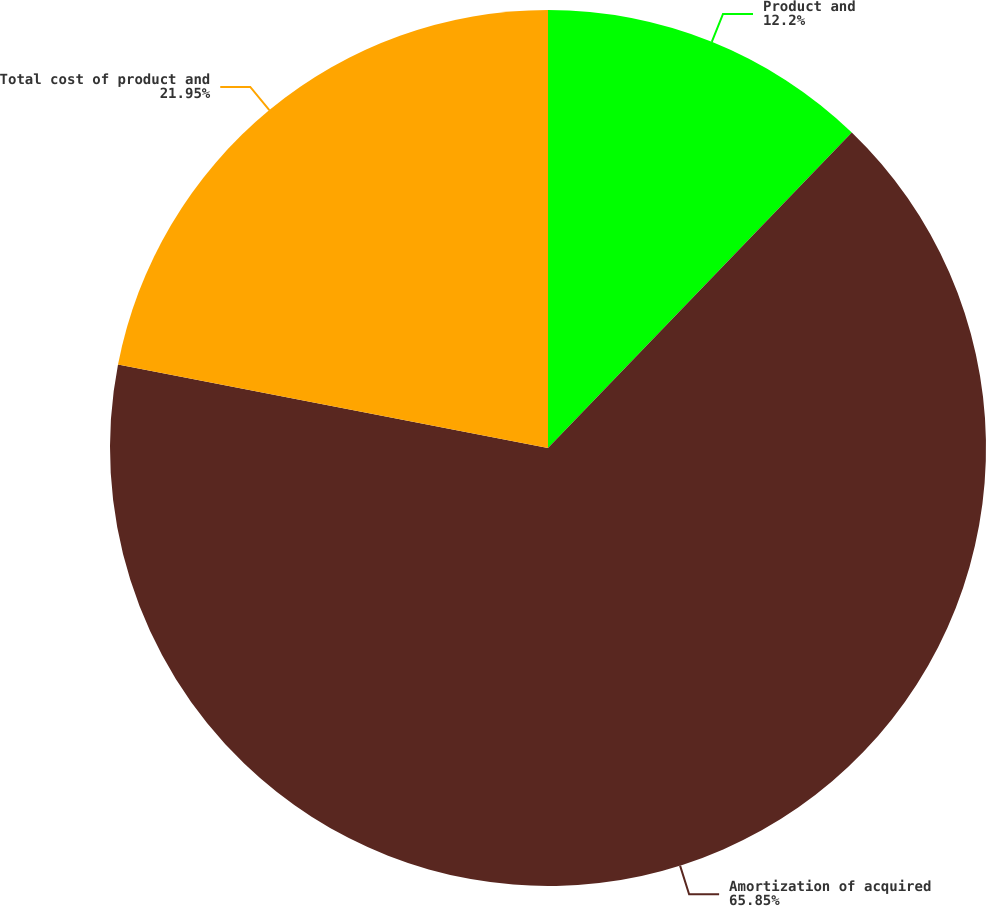<chart> <loc_0><loc_0><loc_500><loc_500><pie_chart><fcel>Product and<fcel>Amortization of acquired<fcel>Total cost of product and<nl><fcel>12.2%<fcel>65.85%<fcel>21.95%<nl></chart> 